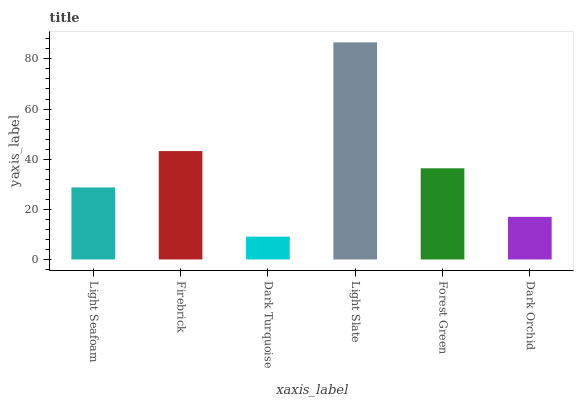Is Dark Turquoise the minimum?
Answer yes or no. Yes. Is Light Slate the maximum?
Answer yes or no. Yes. Is Firebrick the minimum?
Answer yes or no. No. Is Firebrick the maximum?
Answer yes or no. No. Is Firebrick greater than Light Seafoam?
Answer yes or no. Yes. Is Light Seafoam less than Firebrick?
Answer yes or no. Yes. Is Light Seafoam greater than Firebrick?
Answer yes or no. No. Is Firebrick less than Light Seafoam?
Answer yes or no. No. Is Forest Green the high median?
Answer yes or no. Yes. Is Light Seafoam the low median?
Answer yes or no. Yes. Is Dark Turquoise the high median?
Answer yes or no. No. Is Dark Turquoise the low median?
Answer yes or no. No. 